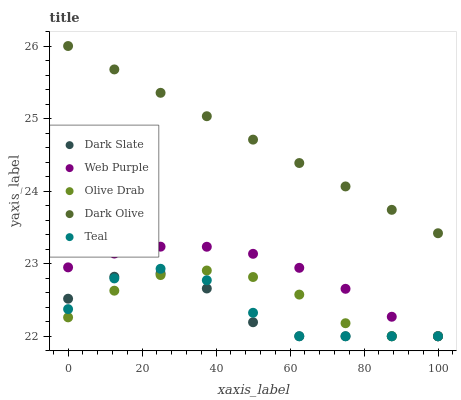Does Dark Slate have the minimum area under the curve?
Answer yes or no. Yes. Does Dark Olive have the maximum area under the curve?
Answer yes or no. Yes. Does Web Purple have the minimum area under the curve?
Answer yes or no. No. Does Web Purple have the maximum area under the curve?
Answer yes or no. No. Is Dark Olive the smoothest?
Answer yes or no. Yes. Is Teal the roughest?
Answer yes or no. Yes. Is Web Purple the smoothest?
Answer yes or no. No. Is Web Purple the roughest?
Answer yes or no. No. Does Dark Slate have the lowest value?
Answer yes or no. Yes. Does Dark Olive have the lowest value?
Answer yes or no. No. Does Dark Olive have the highest value?
Answer yes or no. Yes. Does Web Purple have the highest value?
Answer yes or no. No. Is Web Purple less than Dark Olive?
Answer yes or no. Yes. Is Dark Olive greater than Web Purple?
Answer yes or no. Yes. Does Olive Drab intersect Teal?
Answer yes or no. Yes. Is Olive Drab less than Teal?
Answer yes or no. No. Is Olive Drab greater than Teal?
Answer yes or no. No. Does Web Purple intersect Dark Olive?
Answer yes or no. No. 